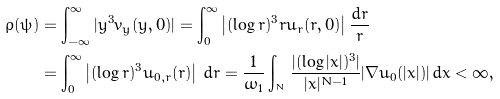<formula> <loc_0><loc_0><loc_500><loc_500>\varrho ( \psi ) & = \int _ { - \infty } ^ { \infty } | y ^ { 3 } v _ { y } ( y , 0 ) | = \int _ { 0 } ^ { \infty } \left | ( \log r ) ^ { 3 } r u _ { r } ( r , 0 ) \right | \frac { d r } { r } \\ & = \int _ { 0 } ^ { \infty } \left | ( \log r ) ^ { 3 } u _ { 0 , r } ( r ) \right | \, d r = \frac { 1 } { \omega _ { 1 } } \int _ { \real ^ { N } } \frac { | ( \log | x | ) ^ { 3 } | } { | x | ^ { N - 1 } } | \nabla u _ { 0 } ( | x | ) | \, d x < \infty ,</formula> 